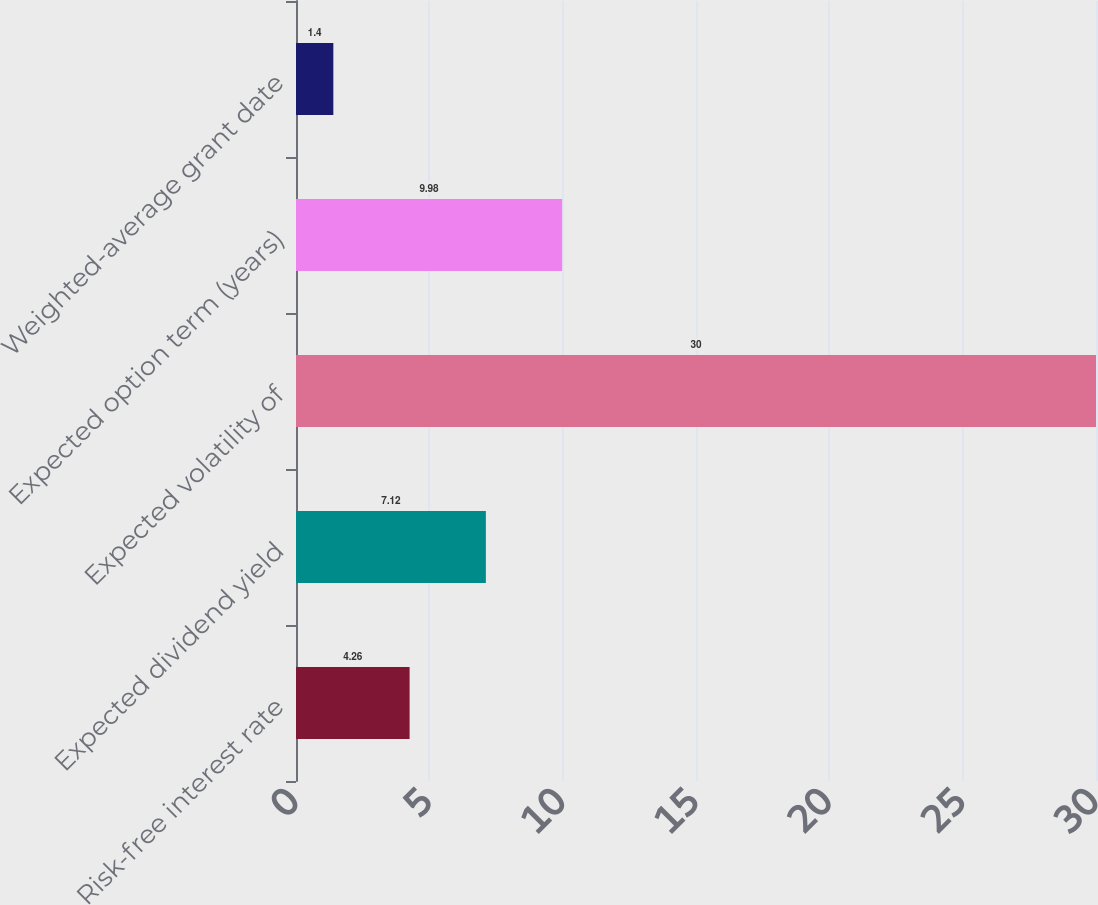<chart> <loc_0><loc_0><loc_500><loc_500><bar_chart><fcel>Risk-free interest rate<fcel>Expected dividend yield<fcel>Expected volatility of<fcel>Expected option term (years)<fcel>Weighted-average grant date<nl><fcel>4.26<fcel>7.12<fcel>30<fcel>9.98<fcel>1.4<nl></chart> 